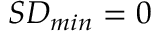<formula> <loc_0><loc_0><loc_500><loc_500>S D _ { \min } = 0</formula> 